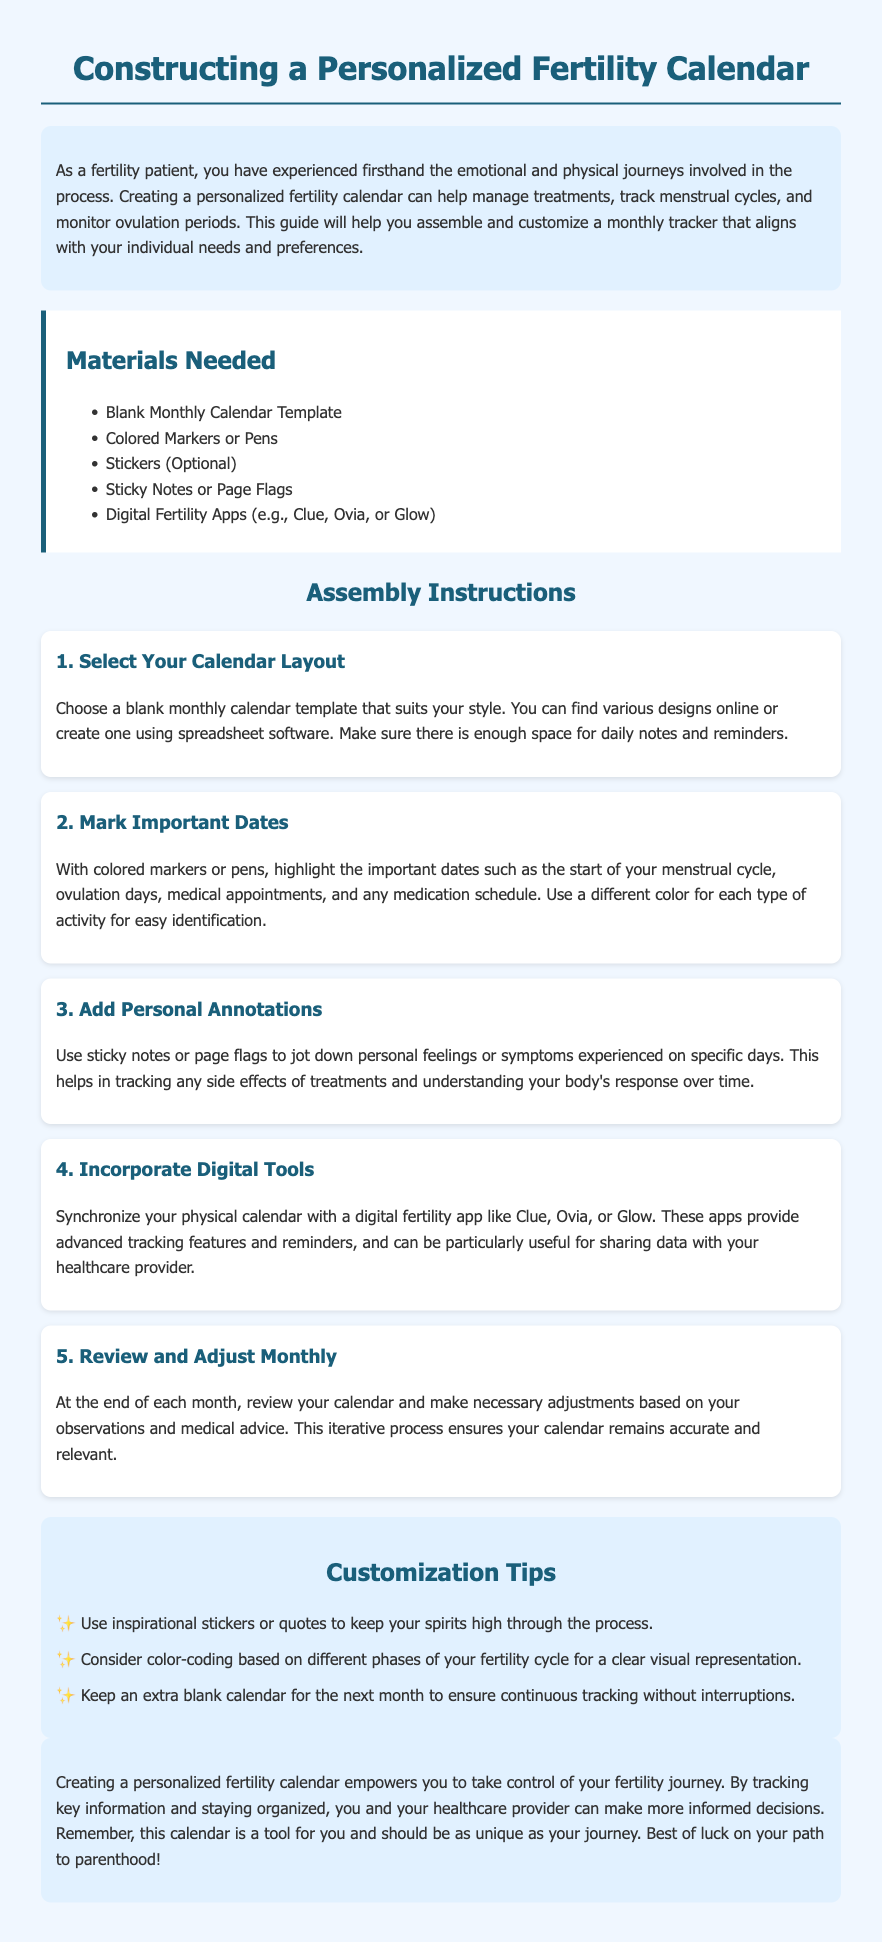What is the title of the document? The title of the document is stated in the header section, which indicates the focus of the guide.
Answer: Constructing a Personalized Fertility Calendar How many materials are listed? The document provides a section that enumerates the materials needed for the project, which can be counted directly.
Answer: 5 What color is used for headings? The document specifies the color scheme in the styled elements for headings.
Answer: #1a5f7a Which app is suggested for digital synchronization? The instructions identify specific digital fertility apps recommended for syncing with your calendar.
Answer: Clue What is the first step in the assembly instructions? The order of the steps is outlined in the assembly instructions, starting with the selection of a calendar layout.
Answer: Select Your Calendar Layout What is the purpose of using sticky notes? The document describes the function of sticky notes within the context of personal tracking.
Answer: Personal feelings or symptoms What type of stickers are encouraged for customization? The customization tips section mentions a specific type of stickers that can enhance the personalization of the calendar.
Answer: Inspirational stickers How often should you review the calendar? The assembly instructions detail how frequently the calendar should be reviewed for adjustments.
Answer: Monthly 